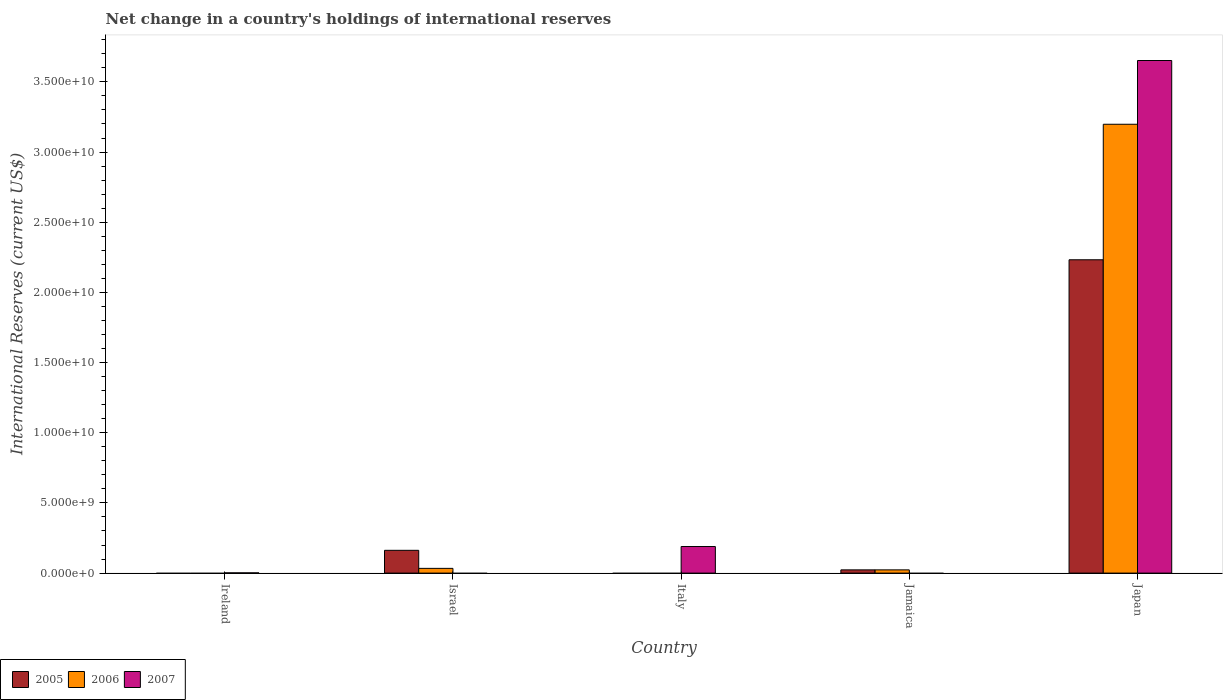Are the number of bars per tick equal to the number of legend labels?
Your answer should be compact. No. How many bars are there on the 4th tick from the right?
Provide a succinct answer. 2. What is the label of the 4th group of bars from the left?
Keep it short and to the point. Jamaica. In how many cases, is the number of bars for a given country not equal to the number of legend labels?
Keep it short and to the point. 4. What is the international reserves in 2006 in Japan?
Make the answer very short. 3.20e+1. Across all countries, what is the maximum international reserves in 2006?
Ensure brevity in your answer.  3.20e+1. What is the total international reserves in 2007 in the graph?
Your answer should be compact. 3.84e+1. What is the difference between the international reserves in 2005 in Jamaica and that in Japan?
Keep it short and to the point. -2.21e+1. What is the difference between the international reserves in 2005 in Israel and the international reserves in 2006 in Ireland?
Keep it short and to the point. 1.62e+09. What is the average international reserves in 2007 per country?
Provide a succinct answer. 7.69e+09. What is the difference between the international reserves of/in 2006 and international reserves of/in 2005 in Jamaica?
Provide a short and direct response. 4.15e+05. What is the ratio of the international reserves in 2007 in Ireland to that in Japan?
Provide a succinct answer. 0. What is the difference between the highest and the second highest international reserves in 2006?
Your answer should be very brief. 1.07e+08. What is the difference between the highest and the lowest international reserves in 2006?
Your response must be concise. 3.20e+1. Is it the case that in every country, the sum of the international reserves in 2005 and international reserves in 2007 is greater than the international reserves in 2006?
Offer a very short reply. No. How many bars are there?
Make the answer very short. 9. Are all the bars in the graph horizontal?
Make the answer very short. No. How many countries are there in the graph?
Your response must be concise. 5. Does the graph contain any zero values?
Provide a short and direct response. Yes. How many legend labels are there?
Provide a short and direct response. 3. How are the legend labels stacked?
Make the answer very short. Horizontal. What is the title of the graph?
Offer a very short reply. Net change in a country's holdings of international reserves. What is the label or title of the X-axis?
Provide a succinct answer. Country. What is the label or title of the Y-axis?
Keep it short and to the point. International Reserves (current US$). What is the International Reserves (current US$) of 2005 in Ireland?
Offer a very short reply. 0. What is the International Reserves (current US$) in 2006 in Ireland?
Provide a short and direct response. 0. What is the International Reserves (current US$) in 2007 in Ireland?
Give a very brief answer. 1.60e+07. What is the International Reserves (current US$) of 2005 in Israel?
Offer a very short reply. 1.62e+09. What is the International Reserves (current US$) of 2006 in Israel?
Keep it short and to the point. 3.37e+08. What is the International Reserves (current US$) of 2005 in Italy?
Provide a succinct answer. 0. What is the International Reserves (current US$) of 2007 in Italy?
Keep it short and to the point. 1.89e+09. What is the International Reserves (current US$) in 2005 in Jamaica?
Offer a very short reply. 2.30e+08. What is the International Reserves (current US$) in 2006 in Jamaica?
Your answer should be compact. 2.30e+08. What is the International Reserves (current US$) in 2005 in Japan?
Offer a terse response. 2.23e+1. What is the International Reserves (current US$) of 2006 in Japan?
Your answer should be very brief. 3.20e+1. What is the International Reserves (current US$) in 2007 in Japan?
Your answer should be compact. 3.65e+1. Across all countries, what is the maximum International Reserves (current US$) in 2005?
Make the answer very short. 2.23e+1. Across all countries, what is the maximum International Reserves (current US$) of 2006?
Provide a succinct answer. 3.20e+1. Across all countries, what is the maximum International Reserves (current US$) in 2007?
Keep it short and to the point. 3.65e+1. Across all countries, what is the minimum International Reserves (current US$) of 2005?
Offer a terse response. 0. What is the total International Reserves (current US$) in 2005 in the graph?
Provide a succinct answer. 2.42e+1. What is the total International Reserves (current US$) in 2006 in the graph?
Provide a succinct answer. 3.25e+1. What is the total International Reserves (current US$) in 2007 in the graph?
Provide a short and direct response. 3.84e+1. What is the difference between the International Reserves (current US$) in 2007 in Ireland and that in Italy?
Offer a very short reply. -1.88e+09. What is the difference between the International Reserves (current US$) of 2007 in Ireland and that in Japan?
Your response must be concise. -3.65e+1. What is the difference between the International Reserves (current US$) of 2005 in Israel and that in Jamaica?
Ensure brevity in your answer.  1.39e+09. What is the difference between the International Reserves (current US$) in 2006 in Israel and that in Jamaica?
Provide a short and direct response. 1.07e+08. What is the difference between the International Reserves (current US$) of 2005 in Israel and that in Japan?
Make the answer very short. -2.07e+1. What is the difference between the International Reserves (current US$) of 2006 in Israel and that in Japan?
Offer a terse response. -3.16e+1. What is the difference between the International Reserves (current US$) in 2007 in Italy and that in Japan?
Provide a short and direct response. -3.46e+1. What is the difference between the International Reserves (current US$) of 2005 in Jamaica and that in Japan?
Provide a succinct answer. -2.21e+1. What is the difference between the International Reserves (current US$) of 2006 in Jamaica and that in Japan?
Your answer should be compact. -3.18e+1. What is the difference between the International Reserves (current US$) of 2005 in Israel and the International Reserves (current US$) of 2007 in Italy?
Ensure brevity in your answer.  -2.70e+08. What is the difference between the International Reserves (current US$) of 2006 in Israel and the International Reserves (current US$) of 2007 in Italy?
Make the answer very short. -1.56e+09. What is the difference between the International Reserves (current US$) of 2005 in Israel and the International Reserves (current US$) of 2006 in Jamaica?
Ensure brevity in your answer.  1.39e+09. What is the difference between the International Reserves (current US$) of 2005 in Israel and the International Reserves (current US$) of 2006 in Japan?
Make the answer very short. -3.04e+1. What is the difference between the International Reserves (current US$) of 2005 in Israel and the International Reserves (current US$) of 2007 in Japan?
Your response must be concise. -3.49e+1. What is the difference between the International Reserves (current US$) in 2006 in Israel and the International Reserves (current US$) in 2007 in Japan?
Your answer should be compact. -3.62e+1. What is the difference between the International Reserves (current US$) in 2005 in Jamaica and the International Reserves (current US$) in 2006 in Japan?
Make the answer very short. -3.18e+1. What is the difference between the International Reserves (current US$) in 2005 in Jamaica and the International Reserves (current US$) in 2007 in Japan?
Provide a short and direct response. -3.63e+1. What is the difference between the International Reserves (current US$) of 2006 in Jamaica and the International Reserves (current US$) of 2007 in Japan?
Your response must be concise. -3.63e+1. What is the average International Reserves (current US$) in 2005 per country?
Ensure brevity in your answer.  4.84e+09. What is the average International Reserves (current US$) in 2006 per country?
Provide a short and direct response. 6.51e+09. What is the average International Reserves (current US$) in 2007 per country?
Your answer should be very brief. 7.69e+09. What is the difference between the International Reserves (current US$) of 2005 and International Reserves (current US$) of 2006 in Israel?
Your response must be concise. 1.29e+09. What is the difference between the International Reserves (current US$) in 2005 and International Reserves (current US$) in 2006 in Jamaica?
Offer a terse response. -4.15e+05. What is the difference between the International Reserves (current US$) of 2005 and International Reserves (current US$) of 2006 in Japan?
Keep it short and to the point. -9.66e+09. What is the difference between the International Reserves (current US$) in 2005 and International Reserves (current US$) in 2007 in Japan?
Provide a short and direct response. -1.42e+1. What is the difference between the International Reserves (current US$) in 2006 and International Reserves (current US$) in 2007 in Japan?
Offer a very short reply. -4.54e+09. What is the ratio of the International Reserves (current US$) in 2007 in Ireland to that in Italy?
Provide a succinct answer. 0.01. What is the ratio of the International Reserves (current US$) in 2007 in Ireland to that in Japan?
Keep it short and to the point. 0. What is the ratio of the International Reserves (current US$) in 2005 in Israel to that in Jamaica?
Provide a short and direct response. 7.06. What is the ratio of the International Reserves (current US$) in 2006 in Israel to that in Jamaica?
Give a very brief answer. 1.46. What is the ratio of the International Reserves (current US$) of 2005 in Israel to that in Japan?
Make the answer very short. 0.07. What is the ratio of the International Reserves (current US$) in 2006 in Israel to that in Japan?
Offer a very short reply. 0.01. What is the ratio of the International Reserves (current US$) in 2007 in Italy to that in Japan?
Keep it short and to the point. 0.05. What is the ratio of the International Reserves (current US$) in 2005 in Jamaica to that in Japan?
Offer a terse response. 0.01. What is the ratio of the International Reserves (current US$) of 2006 in Jamaica to that in Japan?
Give a very brief answer. 0.01. What is the difference between the highest and the second highest International Reserves (current US$) in 2005?
Provide a short and direct response. 2.07e+1. What is the difference between the highest and the second highest International Reserves (current US$) of 2006?
Your answer should be very brief. 3.16e+1. What is the difference between the highest and the second highest International Reserves (current US$) in 2007?
Offer a terse response. 3.46e+1. What is the difference between the highest and the lowest International Reserves (current US$) of 2005?
Offer a very short reply. 2.23e+1. What is the difference between the highest and the lowest International Reserves (current US$) of 2006?
Make the answer very short. 3.20e+1. What is the difference between the highest and the lowest International Reserves (current US$) of 2007?
Ensure brevity in your answer.  3.65e+1. 